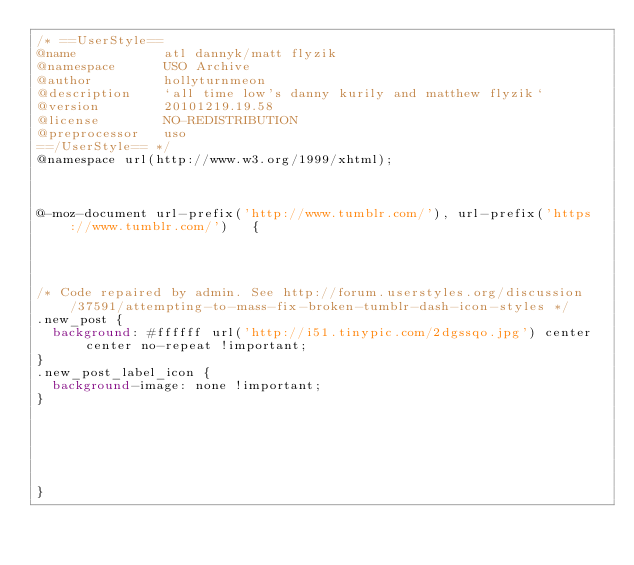Convert code to text. <code><loc_0><loc_0><loc_500><loc_500><_CSS_>/* ==UserStyle==
@name           atl dannyk/matt flyzik
@namespace      USO Archive
@author         hollyturnmeon
@description    `all time low's danny kurily and matthew flyzik`
@version        20101219.19.58
@license        NO-REDISTRIBUTION
@preprocessor   uso
==/UserStyle== */
@namespace url(http://www.w3.org/1999/xhtml);



@-moz-document url-prefix('http://www.tumblr.com/'), url-prefix('https://www.tumblr.com/')   {




/* Code repaired by admin. See http://forum.userstyles.org/discussion/37591/attempting-to-mass-fix-broken-tumblr-dash-icon-styles */
.new_post {
	background: #ffffff url('http://i51.tinypic.com/2dgssqo.jpg') center center no-repeat !important;
}
.new_post_label_icon {
	background-image: none !important;
}






}</code> 